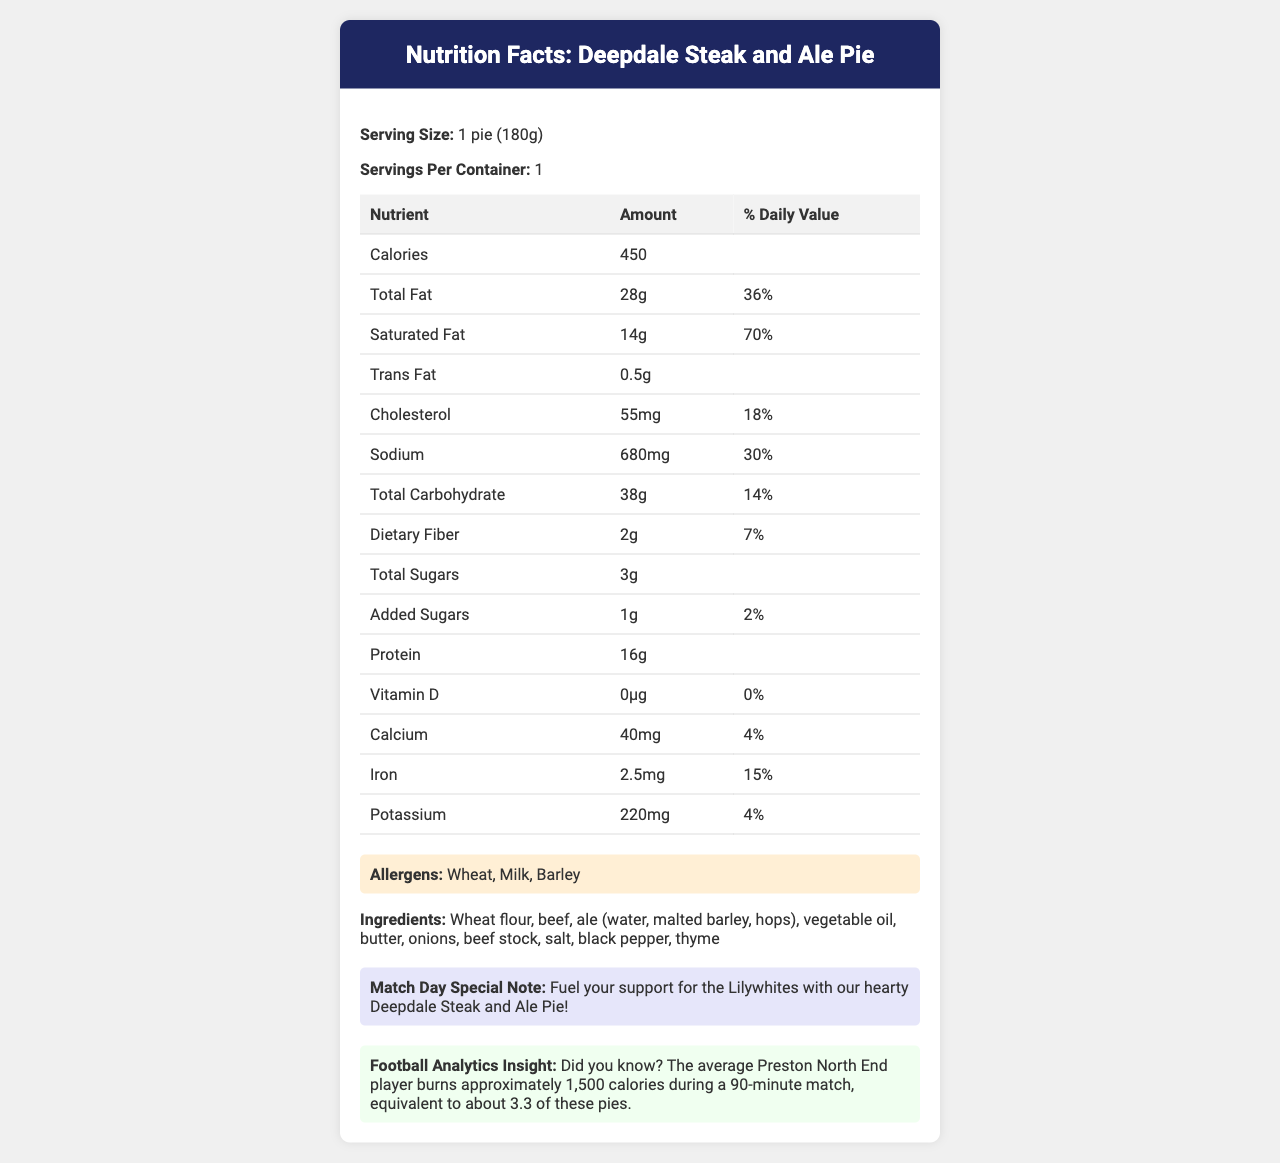what is the serving size of the Deepdale Steak and Ale Pie? The serving size is specified as "1 pie (180g)" in the Nutrition Facts section.
Answer: 1 pie (180g) how many calories are in one serving of the pie? The document specifies that each serving of the pie contains 450 calories.
Answer: 450 how much total fat is in one serving of the pie? The total fat content per serving is listed as 28 grams in the Nutrition Facts table.
Answer: 28g what percent daily value of saturated fat does the pie contain? The percentage daily value for saturated fat is 70%, as shown in the Nutrition Facts table.
Answer: 70% how much sodium does the pie contain? The sodium content per serving is listed as 680 milligrams in the Nutrition Facts section.
Answer: 680mg which allergen is NOT listed for the Deepdale Steak and Ale Pie? A. Wheat B. Soy C. Barley D. Milk The allergens listed are Wheat, Milk, and Barley. Soy is not mentioned.
Answer: B. Soy what are the main ingredients in the pie? The main ingredients are detailed in the Ingredients section of the document.
Answer: Wheat flour, beef, ale (water, malted barley, hops), vegetable oil, butter, onions, beef stock, salt, black pepper, thyme how much iron does the pie provide? The iron content per serving is listed as 2.5 milligrams in the Nutrition Facts table.
Answer: 2.5mg how many calories does an average Preston North End player burn during a match? This information is provided in the Football Analytics Insight section.
Answer: 1,500 calories for how long does the average Preston North End player burn 1,500 calories during a match? According to the Football Analytics Insight, the average player burns 1,500 calories during a 90-minute match.
Answer: 90 minutes what percentage of the daily value of cholesterol does the pie provide? The Nutrition Facts table states that the pie provides 18% of the daily value for cholesterol.
Answer: 18% True or False: The pie contains added sugars. The document states that the pie contains 1 gram of added sugars, which is 2% of the daily value.
Answer: True how many servings are in one container of the pie? The document specifies that there is 1 serving per container.
Answer: 1 which is a match day special note mentioned about the pie? A. Limited Edition B. Gluten-Free C. Fuel your support for the Lilywhites D. Vegan Friendly The Match Day Special Note mentions, "Fuel your support for the Lilywhites with our hearty Deepdale Steak and Ale Pie!"
Answer: C. Fuel your support for the Lilywhites how many grams of dietary fiber does the pie have? The dietary fiber content per serving is listed as 2 grams in the Nutrition Facts table.
Answer: 2 grams what is the total amount of carbohydrates present in one serving of the pie? The document specifies that there are 38 grams of total carbohydrates in one serving.
Answer: 38 grams how much protein does the pie contain? The pie contains 16 grams of protein per serving, as listed in the Nutrition Facts table.
Answer: 16 grams how much potassium does the pie provide? The potassium content per serving is listed as 220 milligrams in the Nutrition Facts section.
Answer: 220mg Summary: Describe the overall nutritional content and key highlights of the Deepdale Steak and Ale Pie. The explanation provides a detailed summary of the nutritional values and key highlights mentioned in the information provided.
Answer: The Deepdale Steak and Ale Pie contains 450 calories per serving, with 28 grams of total fat (36% DV), 14 grams of saturated fat (70% DV), 0.5 grams of trans fat, 55 milligrams of cholesterol (18% DV), and 680 milligrams of sodium (30% DV). It provides 38 grams of total carbohydrates (14% DV), 2 grams of dietary fiber (7% DV), and 16 grams of protein. The pie also contains small amounts of calcium, iron, and potassium. Key highlights include its hearty ingredients suitable for match day and a note that an average Preston North End player burns 1,500 calories per match, which equates to about 3.3 of these pies. 